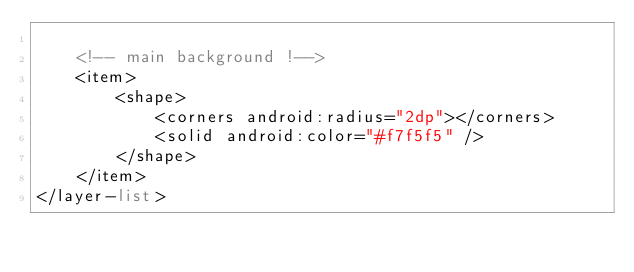<code> <loc_0><loc_0><loc_500><loc_500><_XML_>
    <!-- main background !-->
    <item>
        <shape>
            <corners android:radius="2dp"></corners>
            <solid android:color="#f7f5f5" />
        </shape>
    </item>
</layer-list></code> 